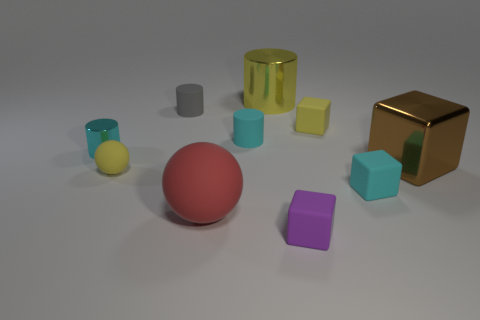What number of cyan cylinders are in front of the rubber block in front of the big object that is on the left side of the large yellow shiny cylinder?
Provide a short and direct response. 0. What is the color of the metallic object that is on the right side of the yellow rubber cube?
Give a very brief answer. Brown. What shape is the tiny yellow rubber object on the left side of the small block that is in front of the large sphere?
Your response must be concise. Sphere. Do the tiny matte ball and the large shiny cylinder have the same color?
Keep it short and to the point. Yes. How many balls are either large cyan objects or tiny cyan matte objects?
Your answer should be compact. 0. There is a thing that is both on the left side of the cyan matte cylinder and in front of the small sphere; what is it made of?
Your answer should be compact. Rubber. What number of small cyan rubber blocks are to the right of the red sphere?
Your answer should be compact. 1. Does the small cyan object in front of the small cyan shiny object have the same material as the small block that is behind the tiny cyan metallic object?
Keep it short and to the point. Yes. How many things are metallic cylinders left of the gray matte cylinder or small things?
Your response must be concise. 7. Is the number of tiny cyan matte things behind the big metallic block less than the number of tiny cyan cylinders in front of the big cylinder?
Your response must be concise. Yes. 